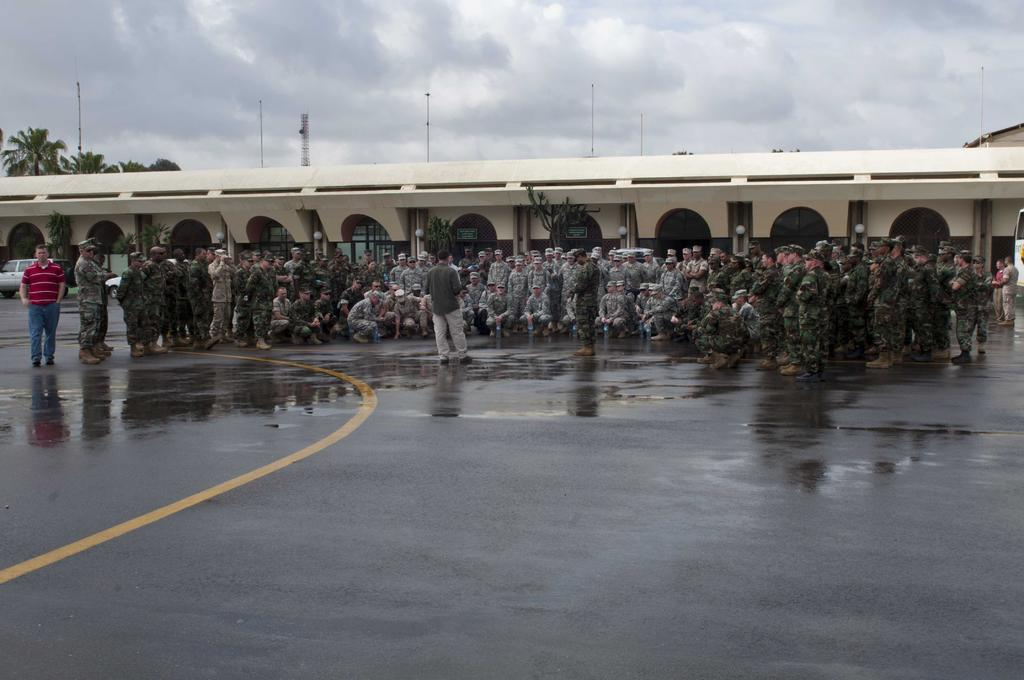What is happening on the road in the image? There is a group of people on the road in the image. What can be seen in the background of the image? In the background, there are cars, plants, at least one building, lights, poles, trees, and the sky with clouds. How many elements can be identified in the background of the image? There are eight elements identifiable in the background: cars, plants, a building, lights, poles, trees, the sky, and clouds. What is the chance of the group of people falling asleep on the road in the image? There is no indication in the image that the group of people is falling asleep or has any intention of doing so. 